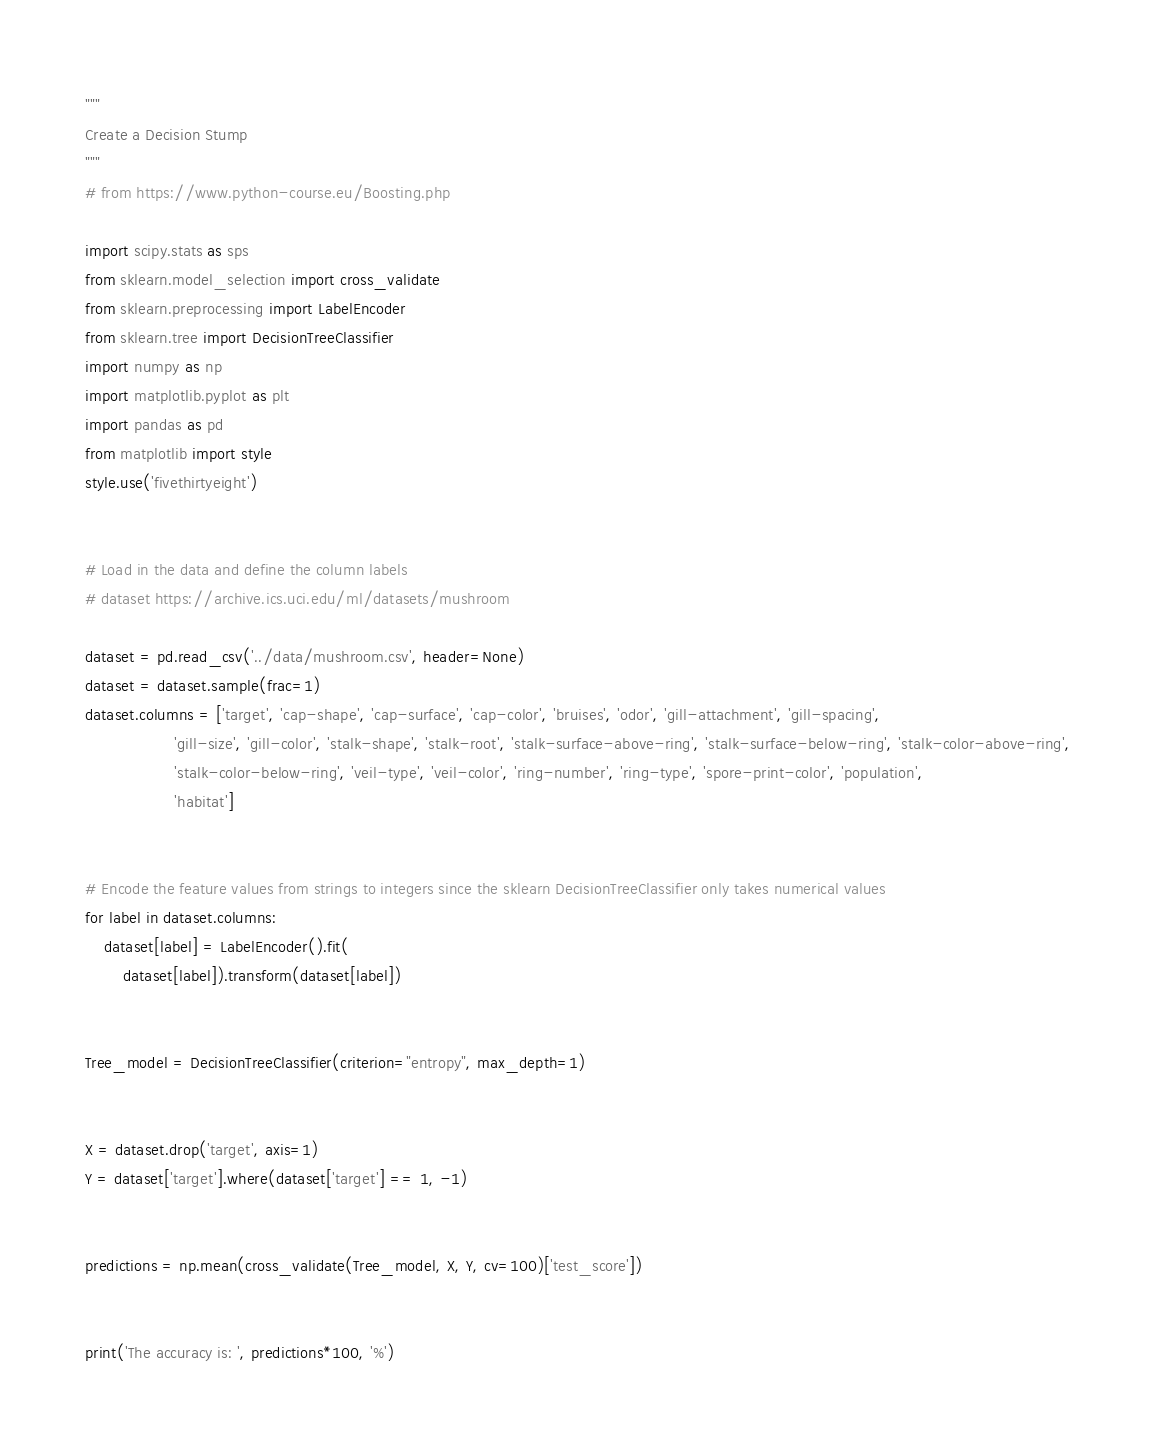Convert code to text. <code><loc_0><loc_0><loc_500><loc_500><_Python_>"""
Create a Decision Stump
"""
# from https://www.python-course.eu/Boosting.php

import scipy.stats as sps
from sklearn.model_selection import cross_validate
from sklearn.preprocessing import LabelEncoder
from sklearn.tree import DecisionTreeClassifier
import numpy as np
import matplotlib.pyplot as plt
import pandas as pd
from matplotlib import style
style.use('fivethirtyeight')


# Load in the data and define the column labels
# dataset https://archive.ics.uci.edu/ml/datasets/mushroom

dataset = pd.read_csv('../data/mushroom.csv', header=None)
dataset = dataset.sample(frac=1)
dataset.columns = ['target', 'cap-shape', 'cap-surface', 'cap-color', 'bruises', 'odor', 'gill-attachment', 'gill-spacing',
                   'gill-size', 'gill-color', 'stalk-shape', 'stalk-root', 'stalk-surface-above-ring', 'stalk-surface-below-ring', 'stalk-color-above-ring',
                   'stalk-color-below-ring', 'veil-type', 'veil-color', 'ring-number', 'ring-type', 'spore-print-color', 'population',
                   'habitat']


# Encode the feature values from strings to integers since the sklearn DecisionTreeClassifier only takes numerical values
for label in dataset.columns:
    dataset[label] = LabelEncoder().fit(
        dataset[label]).transform(dataset[label])


Tree_model = DecisionTreeClassifier(criterion="entropy", max_depth=1)


X = dataset.drop('target', axis=1)
Y = dataset['target'].where(dataset['target'] == 1, -1)


predictions = np.mean(cross_validate(Tree_model, X, Y, cv=100)['test_score'])


print('The accuracy is: ', predictions*100, '%')
</code> 